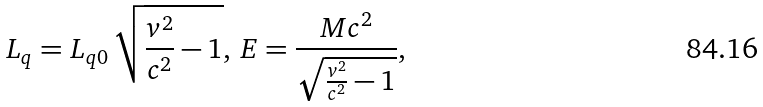Convert formula to latex. <formula><loc_0><loc_0><loc_500><loc_500>L _ { q } = L _ { q 0 } \, \sqrt { \frac { v ^ { 2 } } { c ^ { 2 } } - 1 } , \, E = \frac { M c ^ { 2 } } { \sqrt { \frac { v ^ { 2 } } { c ^ { 2 } } - 1 } } ,</formula> 